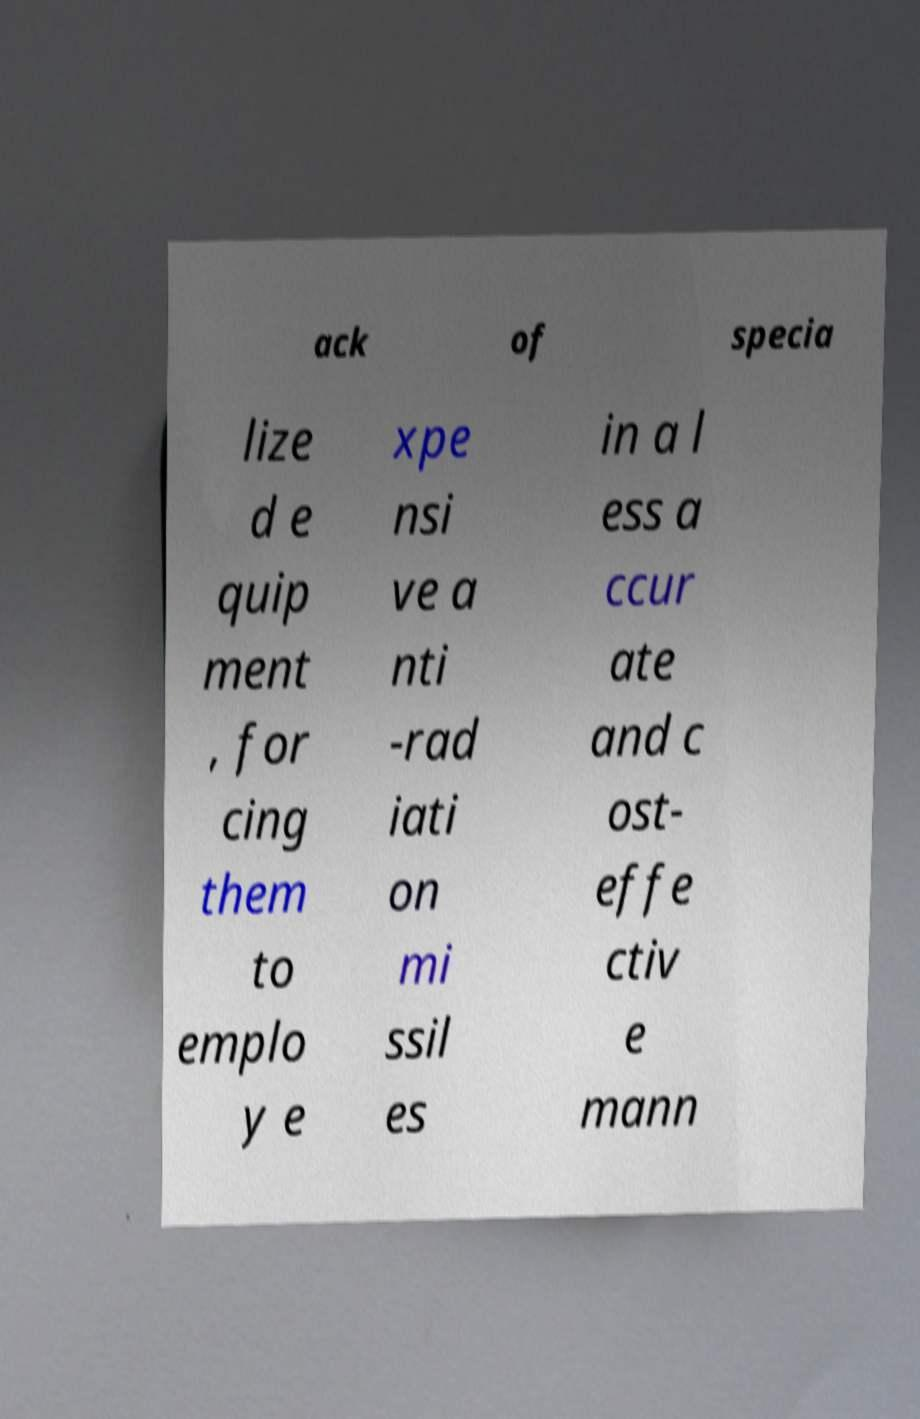Please read and relay the text visible in this image. What does it say? ack of specia lize d e quip ment , for cing them to emplo y e xpe nsi ve a nti -rad iati on mi ssil es in a l ess a ccur ate and c ost- effe ctiv e mann 